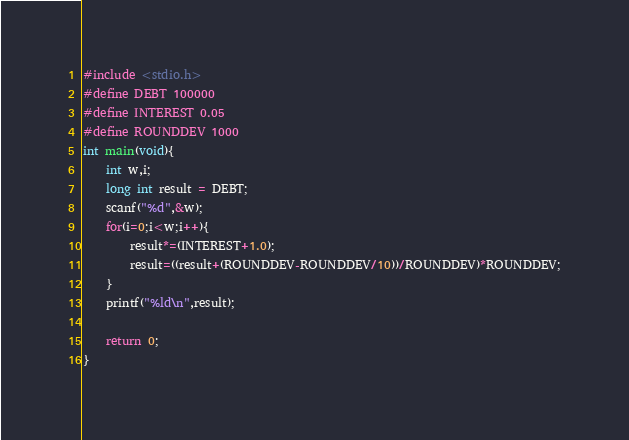<code> <loc_0><loc_0><loc_500><loc_500><_C_>#include <stdio.h>
#define DEBT 100000
#define INTEREST 0.05
#define ROUNDDEV 1000
int main(void){
    int w,i;
    long int result = DEBT;
    scanf("%d",&w);
    for(i=0;i<w;i++){
        result*=(INTEREST+1.0);
        result=((result+(ROUNDDEV-ROUNDDEV/10))/ROUNDDEV)*ROUNDDEV;
    }
    printf("%ld\n",result);
    
    return 0;
}</code> 